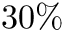Convert formula to latex. <formula><loc_0><loc_0><loc_500><loc_500>3 0 \%</formula> 